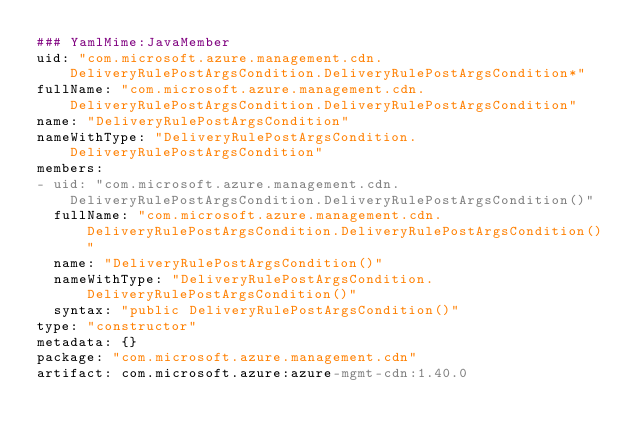<code> <loc_0><loc_0><loc_500><loc_500><_YAML_>### YamlMime:JavaMember
uid: "com.microsoft.azure.management.cdn.DeliveryRulePostArgsCondition.DeliveryRulePostArgsCondition*"
fullName: "com.microsoft.azure.management.cdn.DeliveryRulePostArgsCondition.DeliveryRulePostArgsCondition"
name: "DeliveryRulePostArgsCondition"
nameWithType: "DeliveryRulePostArgsCondition.DeliveryRulePostArgsCondition"
members:
- uid: "com.microsoft.azure.management.cdn.DeliveryRulePostArgsCondition.DeliveryRulePostArgsCondition()"
  fullName: "com.microsoft.azure.management.cdn.DeliveryRulePostArgsCondition.DeliveryRulePostArgsCondition()"
  name: "DeliveryRulePostArgsCondition()"
  nameWithType: "DeliveryRulePostArgsCondition.DeliveryRulePostArgsCondition()"
  syntax: "public DeliveryRulePostArgsCondition()"
type: "constructor"
metadata: {}
package: "com.microsoft.azure.management.cdn"
artifact: com.microsoft.azure:azure-mgmt-cdn:1.40.0
</code> 